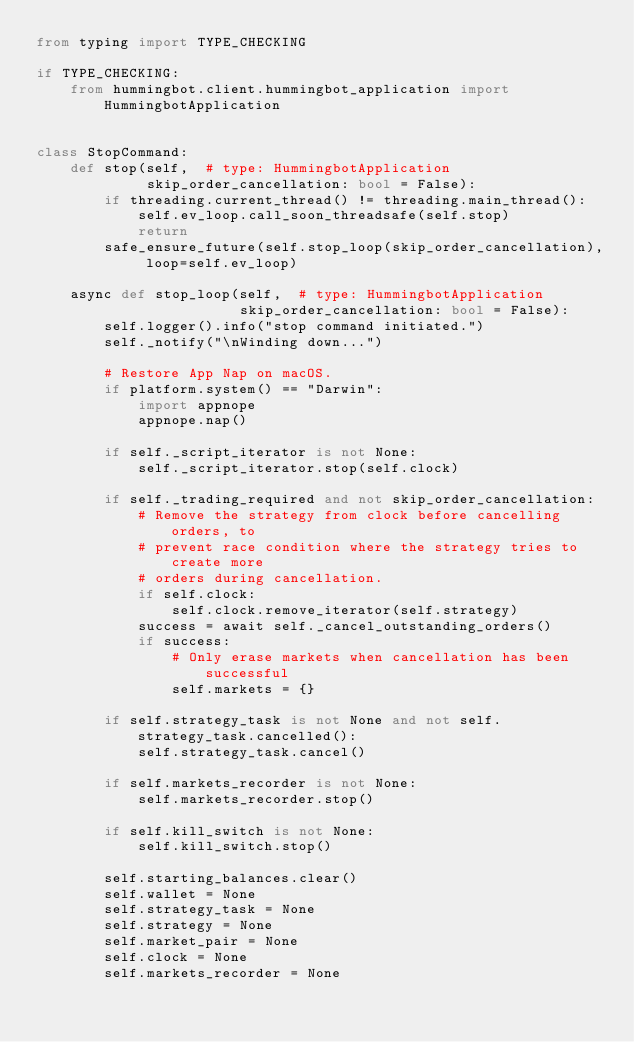<code> <loc_0><loc_0><loc_500><loc_500><_Python_>from typing import TYPE_CHECKING

if TYPE_CHECKING:
    from hummingbot.client.hummingbot_application import HummingbotApplication


class StopCommand:
    def stop(self,  # type: HummingbotApplication
             skip_order_cancellation: bool = False):
        if threading.current_thread() != threading.main_thread():
            self.ev_loop.call_soon_threadsafe(self.stop)
            return
        safe_ensure_future(self.stop_loop(skip_order_cancellation), loop=self.ev_loop)

    async def stop_loop(self,  # type: HummingbotApplication
                        skip_order_cancellation: bool = False):
        self.logger().info("stop command initiated.")
        self._notify("\nWinding down...")

        # Restore App Nap on macOS.
        if platform.system() == "Darwin":
            import appnope
            appnope.nap()

        if self._script_iterator is not None:
            self._script_iterator.stop(self.clock)

        if self._trading_required and not skip_order_cancellation:
            # Remove the strategy from clock before cancelling orders, to
            # prevent race condition where the strategy tries to create more
            # orders during cancellation.
            if self.clock:
                self.clock.remove_iterator(self.strategy)
            success = await self._cancel_outstanding_orders()
            if success:
                # Only erase markets when cancellation has been successful
                self.markets = {}

        if self.strategy_task is not None and not self.strategy_task.cancelled():
            self.strategy_task.cancel()

        if self.markets_recorder is not None:
            self.markets_recorder.stop()

        if self.kill_switch is not None:
            self.kill_switch.stop()

        self.starting_balances.clear()
        self.wallet = None
        self.strategy_task = None
        self.strategy = None
        self.market_pair = None
        self.clock = None
        self.markets_recorder = None
</code> 